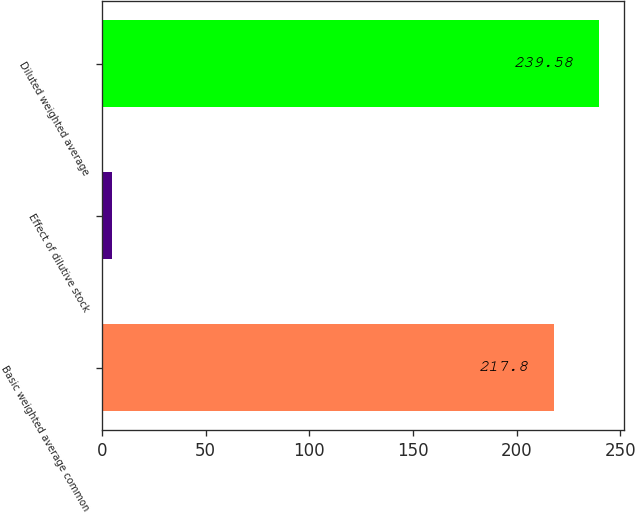Convert chart to OTSL. <chart><loc_0><loc_0><loc_500><loc_500><bar_chart><fcel>Basic weighted average common<fcel>Effect of dilutive stock<fcel>Diluted weighted average<nl><fcel>217.8<fcel>4.8<fcel>239.58<nl></chart> 